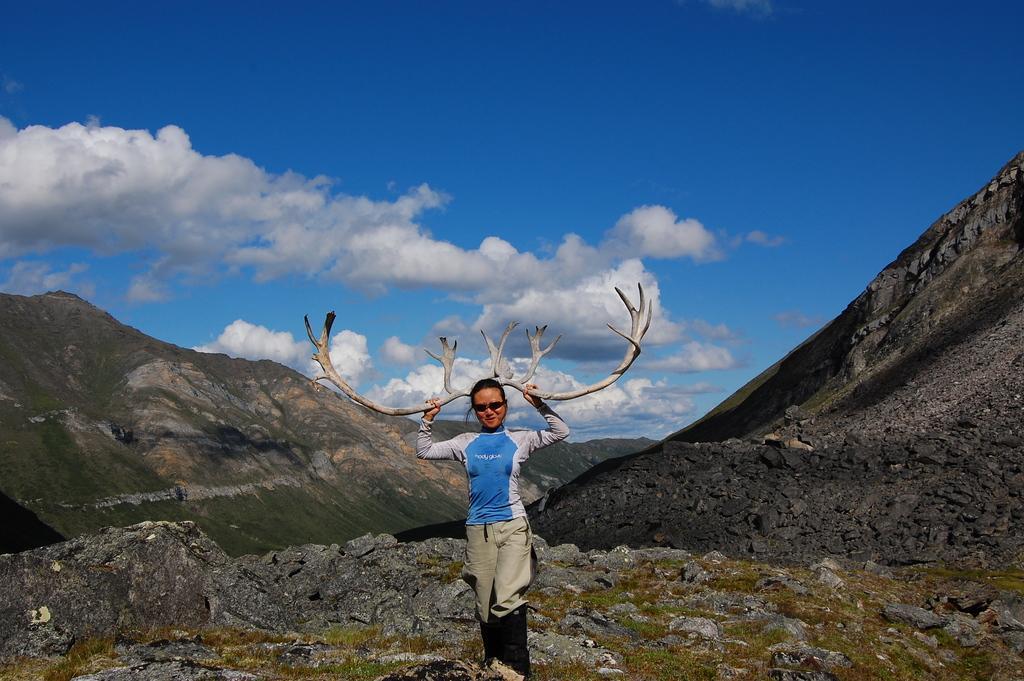Can you describe this image briefly? In this picture, I can see a sky, clouds, and mountains, rock and there is a women standing and wearing a goods and holding an object. 